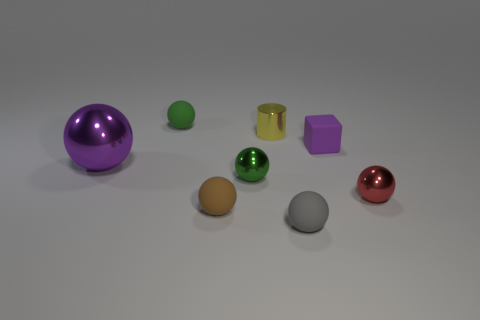Subtract all red balls. How many balls are left? 5 Subtract all tiny green balls. How many balls are left? 4 Subtract all cyan balls. Subtract all cyan cylinders. How many balls are left? 6 Add 2 brown cylinders. How many objects exist? 10 Subtract all cubes. How many objects are left? 7 Subtract 1 purple balls. How many objects are left? 7 Subtract all big objects. Subtract all large yellow metal cylinders. How many objects are left? 7 Add 2 tiny purple objects. How many tiny purple objects are left? 3 Add 4 small green matte objects. How many small green matte objects exist? 5 